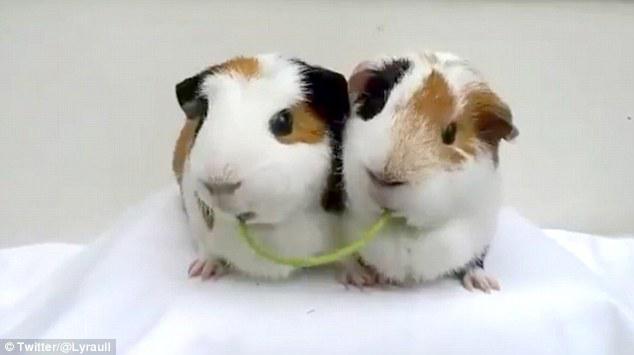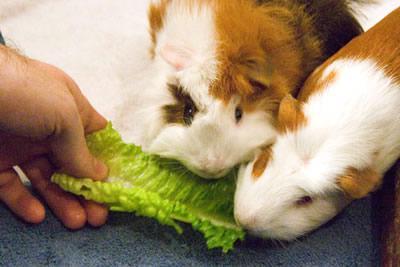The first image is the image on the left, the second image is the image on the right. Examine the images to the left and right. Is the description "Two guinea pigs are chewing on the same item in each of the images." accurate? Answer yes or no. Yes. 